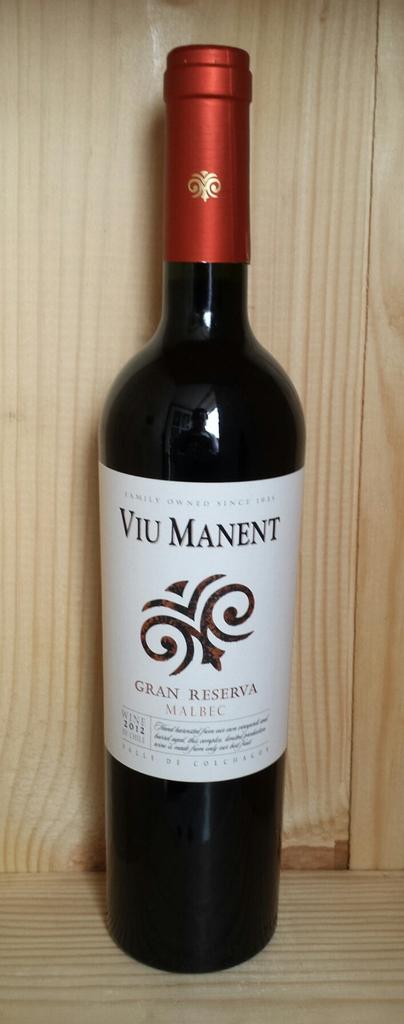What year was this wine made?
Offer a very short reply. 2012. 